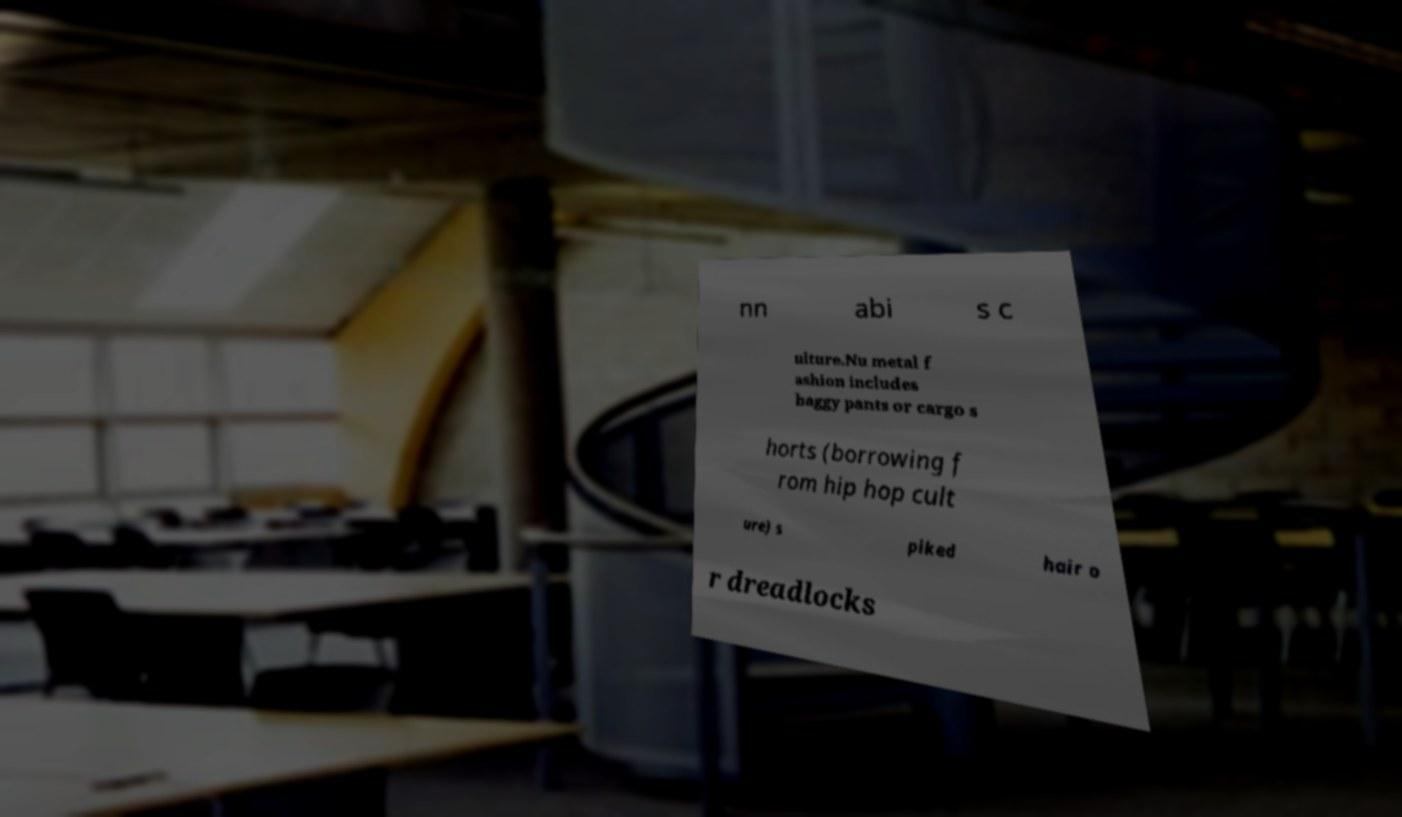Please read and relay the text visible in this image. What does it say? nn abi s c ulture.Nu metal f ashion includes baggy pants or cargo s horts (borrowing f rom hip hop cult ure) s piked hair o r dreadlocks 